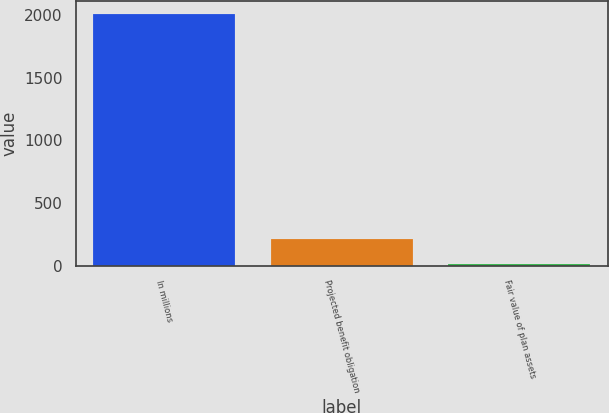Convert chart to OTSL. <chart><loc_0><loc_0><loc_500><loc_500><bar_chart><fcel>In millions<fcel>Projected benefit obligation<fcel>Fair value of plan assets<nl><fcel>2013<fcel>214.35<fcel>14.5<nl></chart> 